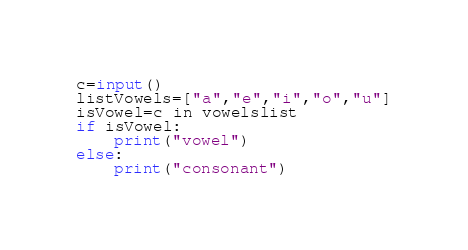Convert code to text. <code><loc_0><loc_0><loc_500><loc_500><_Python_>c=input()
listVowels=["a","e","i","o","u"]
isVowel=c in vowelslist
if isVowel:
    print("vowel")
else:
    print("consonant")</code> 